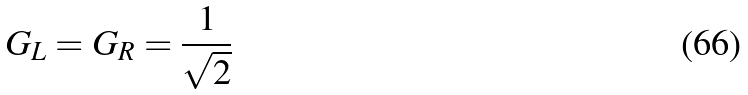<formula> <loc_0><loc_0><loc_500><loc_500>G _ { L } = G _ { R } = \frac { 1 } { \sqrt { 2 } }</formula> 